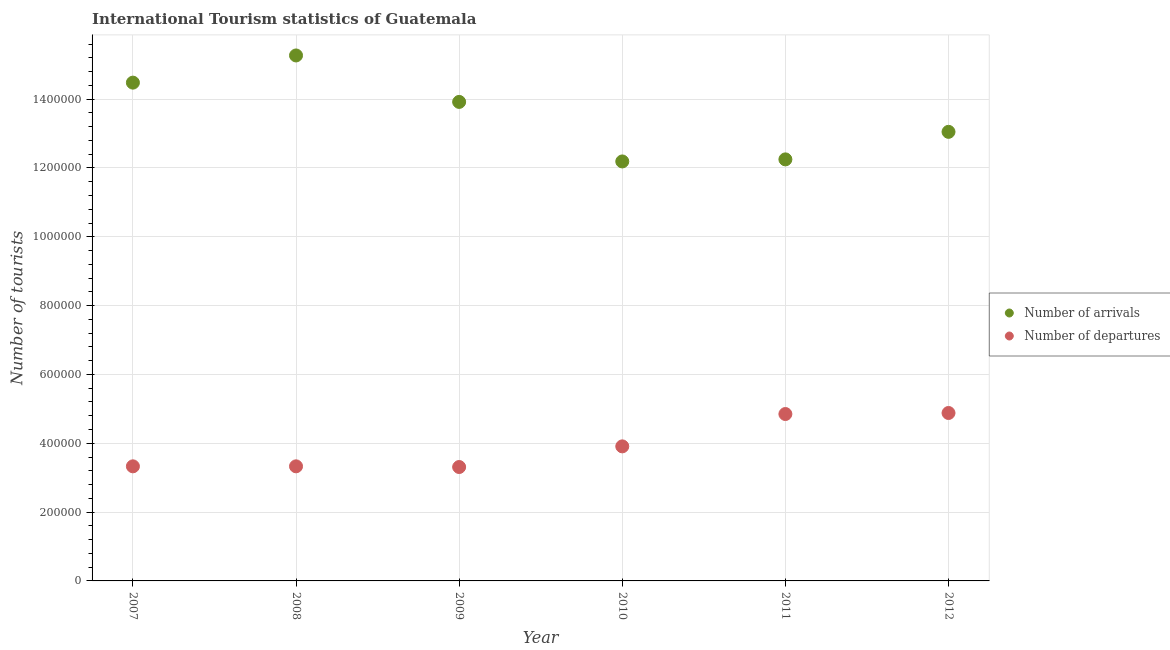Is the number of dotlines equal to the number of legend labels?
Your answer should be compact. Yes. What is the number of tourist arrivals in 2007?
Provide a short and direct response. 1.45e+06. Across all years, what is the maximum number of tourist arrivals?
Provide a succinct answer. 1.53e+06. Across all years, what is the minimum number of tourist departures?
Provide a succinct answer. 3.31e+05. In which year was the number of tourist arrivals maximum?
Ensure brevity in your answer.  2008. In which year was the number of tourist departures minimum?
Your response must be concise. 2009. What is the total number of tourist departures in the graph?
Give a very brief answer. 2.36e+06. What is the difference between the number of tourist departures in 2009 and that in 2011?
Keep it short and to the point. -1.54e+05. What is the difference between the number of tourist departures in 2011 and the number of tourist arrivals in 2009?
Offer a very short reply. -9.07e+05. What is the average number of tourist departures per year?
Offer a terse response. 3.94e+05. In the year 2012, what is the difference between the number of tourist arrivals and number of tourist departures?
Offer a very short reply. 8.17e+05. What is the ratio of the number of tourist departures in 2009 to that in 2012?
Give a very brief answer. 0.68. Is the difference between the number of tourist departures in 2007 and 2009 greater than the difference between the number of tourist arrivals in 2007 and 2009?
Ensure brevity in your answer.  No. What is the difference between the highest and the second highest number of tourist departures?
Keep it short and to the point. 3000. What is the difference between the highest and the lowest number of tourist departures?
Your response must be concise. 1.57e+05. In how many years, is the number of tourist departures greater than the average number of tourist departures taken over all years?
Your response must be concise. 2. Is the sum of the number of tourist departures in 2010 and 2011 greater than the maximum number of tourist arrivals across all years?
Offer a terse response. No. Does the number of tourist arrivals monotonically increase over the years?
Your answer should be compact. No. Is the number of tourist arrivals strictly greater than the number of tourist departures over the years?
Give a very brief answer. Yes. How many dotlines are there?
Ensure brevity in your answer.  2. How many years are there in the graph?
Your answer should be very brief. 6. Does the graph contain any zero values?
Offer a terse response. No. Does the graph contain grids?
Offer a very short reply. Yes. What is the title of the graph?
Keep it short and to the point. International Tourism statistics of Guatemala. Does "Electricity and heat production" appear as one of the legend labels in the graph?
Provide a succinct answer. No. What is the label or title of the X-axis?
Make the answer very short. Year. What is the label or title of the Y-axis?
Give a very brief answer. Number of tourists. What is the Number of tourists of Number of arrivals in 2007?
Provide a short and direct response. 1.45e+06. What is the Number of tourists of Number of departures in 2007?
Offer a very short reply. 3.33e+05. What is the Number of tourists of Number of arrivals in 2008?
Ensure brevity in your answer.  1.53e+06. What is the Number of tourists of Number of departures in 2008?
Keep it short and to the point. 3.33e+05. What is the Number of tourists in Number of arrivals in 2009?
Offer a terse response. 1.39e+06. What is the Number of tourists in Number of departures in 2009?
Make the answer very short. 3.31e+05. What is the Number of tourists of Number of arrivals in 2010?
Your answer should be very brief. 1.22e+06. What is the Number of tourists in Number of departures in 2010?
Keep it short and to the point. 3.91e+05. What is the Number of tourists in Number of arrivals in 2011?
Offer a very short reply. 1.22e+06. What is the Number of tourists of Number of departures in 2011?
Your answer should be very brief. 4.85e+05. What is the Number of tourists in Number of arrivals in 2012?
Your answer should be very brief. 1.30e+06. What is the Number of tourists in Number of departures in 2012?
Give a very brief answer. 4.88e+05. Across all years, what is the maximum Number of tourists of Number of arrivals?
Ensure brevity in your answer.  1.53e+06. Across all years, what is the maximum Number of tourists in Number of departures?
Offer a terse response. 4.88e+05. Across all years, what is the minimum Number of tourists of Number of arrivals?
Ensure brevity in your answer.  1.22e+06. Across all years, what is the minimum Number of tourists of Number of departures?
Your answer should be very brief. 3.31e+05. What is the total Number of tourists in Number of arrivals in the graph?
Make the answer very short. 8.12e+06. What is the total Number of tourists in Number of departures in the graph?
Keep it short and to the point. 2.36e+06. What is the difference between the Number of tourists in Number of arrivals in 2007 and that in 2008?
Your answer should be compact. -7.90e+04. What is the difference between the Number of tourists of Number of departures in 2007 and that in 2008?
Ensure brevity in your answer.  0. What is the difference between the Number of tourists of Number of arrivals in 2007 and that in 2009?
Offer a terse response. 5.60e+04. What is the difference between the Number of tourists of Number of arrivals in 2007 and that in 2010?
Give a very brief answer. 2.29e+05. What is the difference between the Number of tourists in Number of departures in 2007 and that in 2010?
Provide a succinct answer. -5.80e+04. What is the difference between the Number of tourists in Number of arrivals in 2007 and that in 2011?
Ensure brevity in your answer.  2.23e+05. What is the difference between the Number of tourists in Number of departures in 2007 and that in 2011?
Give a very brief answer. -1.52e+05. What is the difference between the Number of tourists in Number of arrivals in 2007 and that in 2012?
Ensure brevity in your answer.  1.43e+05. What is the difference between the Number of tourists in Number of departures in 2007 and that in 2012?
Give a very brief answer. -1.55e+05. What is the difference between the Number of tourists of Number of arrivals in 2008 and that in 2009?
Offer a very short reply. 1.35e+05. What is the difference between the Number of tourists in Number of arrivals in 2008 and that in 2010?
Offer a terse response. 3.08e+05. What is the difference between the Number of tourists in Number of departures in 2008 and that in 2010?
Make the answer very short. -5.80e+04. What is the difference between the Number of tourists in Number of arrivals in 2008 and that in 2011?
Your answer should be very brief. 3.02e+05. What is the difference between the Number of tourists in Number of departures in 2008 and that in 2011?
Make the answer very short. -1.52e+05. What is the difference between the Number of tourists of Number of arrivals in 2008 and that in 2012?
Offer a very short reply. 2.22e+05. What is the difference between the Number of tourists in Number of departures in 2008 and that in 2012?
Provide a succinct answer. -1.55e+05. What is the difference between the Number of tourists of Number of arrivals in 2009 and that in 2010?
Give a very brief answer. 1.73e+05. What is the difference between the Number of tourists of Number of departures in 2009 and that in 2010?
Keep it short and to the point. -6.00e+04. What is the difference between the Number of tourists of Number of arrivals in 2009 and that in 2011?
Your answer should be very brief. 1.67e+05. What is the difference between the Number of tourists in Number of departures in 2009 and that in 2011?
Provide a succinct answer. -1.54e+05. What is the difference between the Number of tourists of Number of arrivals in 2009 and that in 2012?
Offer a very short reply. 8.70e+04. What is the difference between the Number of tourists in Number of departures in 2009 and that in 2012?
Offer a terse response. -1.57e+05. What is the difference between the Number of tourists of Number of arrivals in 2010 and that in 2011?
Keep it short and to the point. -6000. What is the difference between the Number of tourists of Number of departures in 2010 and that in 2011?
Provide a short and direct response. -9.40e+04. What is the difference between the Number of tourists in Number of arrivals in 2010 and that in 2012?
Your answer should be compact. -8.60e+04. What is the difference between the Number of tourists in Number of departures in 2010 and that in 2012?
Provide a short and direct response. -9.70e+04. What is the difference between the Number of tourists of Number of arrivals in 2011 and that in 2012?
Ensure brevity in your answer.  -8.00e+04. What is the difference between the Number of tourists of Number of departures in 2011 and that in 2012?
Make the answer very short. -3000. What is the difference between the Number of tourists in Number of arrivals in 2007 and the Number of tourists in Number of departures in 2008?
Provide a succinct answer. 1.12e+06. What is the difference between the Number of tourists in Number of arrivals in 2007 and the Number of tourists in Number of departures in 2009?
Ensure brevity in your answer.  1.12e+06. What is the difference between the Number of tourists of Number of arrivals in 2007 and the Number of tourists of Number of departures in 2010?
Make the answer very short. 1.06e+06. What is the difference between the Number of tourists of Number of arrivals in 2007 and the Number of tourists of Number of departures in 2011?
Your response must be concise. 9.63e+05. What is the difference between the Number of tourists in Number of arrivals in 2007 and the Number of tourists in Number of departures in 2012?
Offer a terse response. 9.60e+05. What is the difference between the Number of tourists of Number of arrivals in 2008 and the Number of tourists of Number of departures in 2009?
Your answer should be compact. 1.20e+06. What is the difference between the Number of tourists in Number of arrivals in 2008 and the Number of tourists in Number of departures in 2010?
Your answer should be compact. 1.14e+06. What is the difference between the Number of tourists in Number of arrivals in 2008 and the Number of tourists in Number of departures in 2011?
Provide a short and direct response. 1.04e+06. What is the difference between the Number of tourists in Number of arrivals in 2008 and the Number of tourists in Number of departures in 2012?
Your response must be concise. 1.04e+06. What is the difference between the Number of tourists of Number of arrivals in 2009 and the Number of tourists of Number of departures in 2010?
Give a very brief answer. 1.00e+06. What is the difference between the Number of tourists of Number of arrivals in 2009 and the Number of tourists of Number of departures in 2011?
Your answer should be very brief. 9.07e+05. What is the difference between the Number of tourists of Number of arrivals in 2009 and the Number of tourists of Number of departures in 2012?
Keep it short and to the point. 9.04e+05. What is the difference between the Number of tourists in Number of arrivals in 2010 and the Number of tourists in Number of departures in 2011?
Your response must be concise. 7.34e+05. What is the difference between the Number of tourists of Number of arrivals in 2010 and the Number of tourists of Number of departures in 2012?
Provide a short and direct response. 7.31e+05. What is the difference between the Number of tourists of Number of arrivals in 2011 and the Number of tourists of Number of departures in 2012?
Ensure brevity in your answer.  7.37e+05. What is the average Number of tourists of Number of arrivals per year?
Provide a short and direct response. 1.35e+06. What is the average Number of tourists of Number of departures per year?
Provide a succinct answer. 3.94e+05. In the year 2007, what is the difference between the Number of tourists in Number of arrivals and Number of tourists in Number of departures?
Offer a terse response. 1.12e+06. In the year 2008, what is the difference between the Number of tourists in Number of arrivals and Number of tourists in Number of departures?
Your answer should be very brief. 1.19e+06. In the year 2009, what is the difference between the Number of tourists in Number of arrivals and Number of tourists in Number of departures?
Provide a short and direct response. 1.06e+06. In the year 2010, what is the difference between the Number of tourists in Number of arrivals and Number of tourists in Number of departures?
Keep it short and to the point. 8.28e+05. In the year 2011, what is the difference between the Number of tourists of Number of arrivals and Number of tourists of Number of departures?
Give a very brief answer. 7.40e+05. In the year 2012, what is the difference between the Number of tourists in Number of arrivals and Number of tourists in Number of departures?
Your answer should be compact. 8.17e+05. What is the ratio of the Number of tourists in Number of arrivals in 2007 to that in 2008?
Offer a very short reply. 0.95. What is the ratio of the Number of tourists in Number of departures in 2007 to that in 2008?
Keep it short and to the point. 1. What is the ratio of the Number of tourists in Number of arrivals in 2007 to that in 2009?
Offer a terse response. 1.04. What is the ratio of the Number of tourists of Number of arrivals in 2007 to that in 2010?
Keep it short and to the point. 1.19. What is the ratio of the Number of tourists of Number of departures in 2007 to that in 2010?
Give a very brief answer. 0.85. What is the ratio of the Number of tourists in Number of arrivals in 2007 to that in 2011?
Offer a very short reply. 1.18. What is the ratio of the Number of tourists of Number of departures in 2007 to that in 2011?
Your response must be concise. 0.69. What is the ratio of the Number of tourists of Number of arrivals in 2007 to that in 2012?
Your response must be concise. 1.11. What is the ratio of the Number of tourists in Number of departures in 2007 to that in 2012?
Provide a short and direct response. 0.68. What is the ratio of the Number of tourists in Number of arrivals in 2008 to that in 2009?
Your answer should be very brief. 1.1. What is the ratio of the Number of tourists in Number of arrivals in 2008 to that in 2010?
Keep it short and to the point. 1.25. What is the ratio of the Number of tourists of Number of departures in 2008 to that in 2010?
Offer a very short reply. 0.85. What is the ratio of the Number of tourists of Number of arrivals in 2008 to that in 2011?
Make the answer very short. 1.25. What is the ratio of the Number of tourists in Number of departures in 2008 to that in 2011?
Make the answer very short. 0.69. What is the ratio of the Number of tourists in Number of arrivals in 2008 to that in 2012?
Your response must be concise. 1.17. What is the ratio of the Number of tourists of Number of departures in 2008 to that in 2012?
Provide a short and direct response. 0.68. What is the ratio of the Number of tourists of Number of arrivals in 2009 to that in 2010?
Your answer should be compact. 1.14. What is the ratio of the Number of tourists of Number of departures in 2009 to that in 2010?
Keep it short and to the point. 0.85. What is the ratio of the Number of tourists of Number of arrivals in 2009 to that in 2011?
Keep it short and to the point. 1.14. What is the ratio of the Number of tourists of Number of departures in 2009 to that in 2011?
Ensure brevity in your answer.  0.68. What is the ratio of the Number of tourists of Number of arrivals in 2009 to that in 2012?
Give a very brief answer. 1.07. What is the ratio of the Number of tourists in Number of departures in 2009 to that in 2012?
Provide a succinct answer. 0.68. What is the ratio of the Number of tourists of Number of departures in 2010 to that in 2011?
Offer a very short reply. 0.81. What is the ratio of the Number of tourists in Number of arrivals in 2010 to that in 2012?
Provide a short and direct response. 0.93. What is the ratio of the Number of tourists in Number of departures in 2010 to that in 2012?
Provide a succinct answer. 0.8. What is the ratio of the Number of tourists in Number of arrivals in 2011 to that in 2012?
Provide a succinct answer. 0.94. What is the ratio of the Number of tourists of Number of departures in 2011 to that in 2012?
Give a very brief answer. 0.99. What is the difference between the highest and the second highest Number of tourists in Number of arrivals?
Provide a short and direct response. 7.90e+04. What is the difference between the highest and the second highest Number of tourists of Number of departures?
Keep it short and to the point. 3000. What is the difference between the highest and the lowest Number of tourists of Number of arrivals?
Offer a terse response. 3.08e+05. What is the difference between the highest and the lowest Number of tourists of Number of departures?
Ensure brevity in your answer.  1.57e+05. 